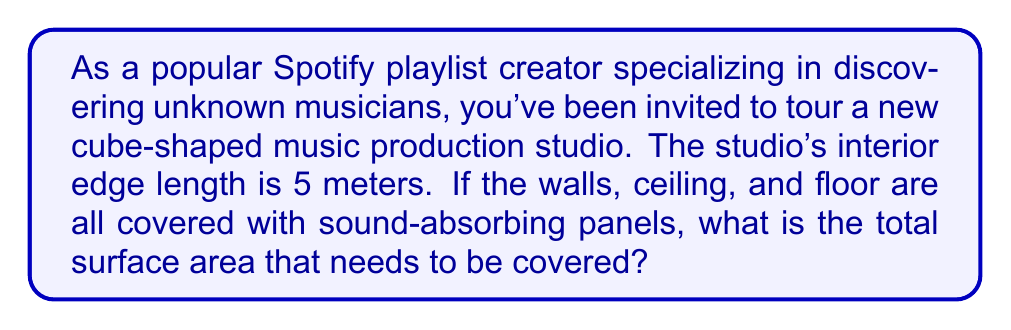Provide a solution to this math problem. To solve this problem, we need to understand the properties of a cube and how to calculate its surface area. Let's break it down step-by-step:

1. A cube has 6 identical square faces.
2. The surface area of a cube is the sum of the areas of all 6 faces.
3. The area of each face is the square of the edge length.

Given:
- The interior edge length of the cube-shaped studio is 5 meters.

Step 1: Calculate the area of one face
Area of one face = $s^2$, where $s$ is the edge length
$A_{face} = 5^2 = 25$ m²

Step 2: Calculate the total surface area
Surface Area = 6 × Area of one face
$SA = 6 \times A_{face}$
$SA = 6 \times 25 = 150$ m²

Therefore, the total surface area that needs to be covered with sound-absorbing panels is 150 square meters.

[asy]
import three;
size(200);
currentprojection=perspective(6,3,2);
draw(unitcube,blue);
label("5 m",(.5,0,-.1));
label("5 m",(-.1,.5,0));
label("5 m",(0,-.1,.5));
[/asy]
Answer: The total surface area to be covered with sound-absorbing panels is 150 m². 